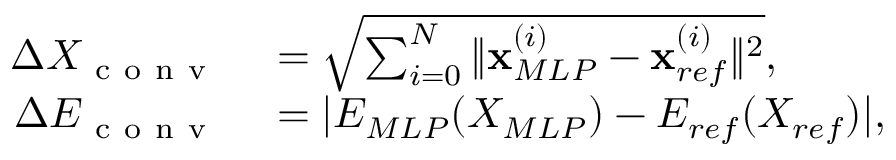Convert formula to latex. <formula><loc_0><loc_0><loc_500><loc_500>\begin{array} { r l } { \Delta X _ { c o n v } } & = \sqrt { \sum _ { i = 0 } ^ { N } \| x _ { M L P } ^ { ( i ) } - x _ { r e f } ^ { ( i ) } \| ^ { 2 } } , } \\ { \Delta E _ { c o n v } } & = | E _ { M L P } ( X _ { M L P } ) - E _ { r e f } ( X _ { r e f } ) | , } \end{array}</formula> 